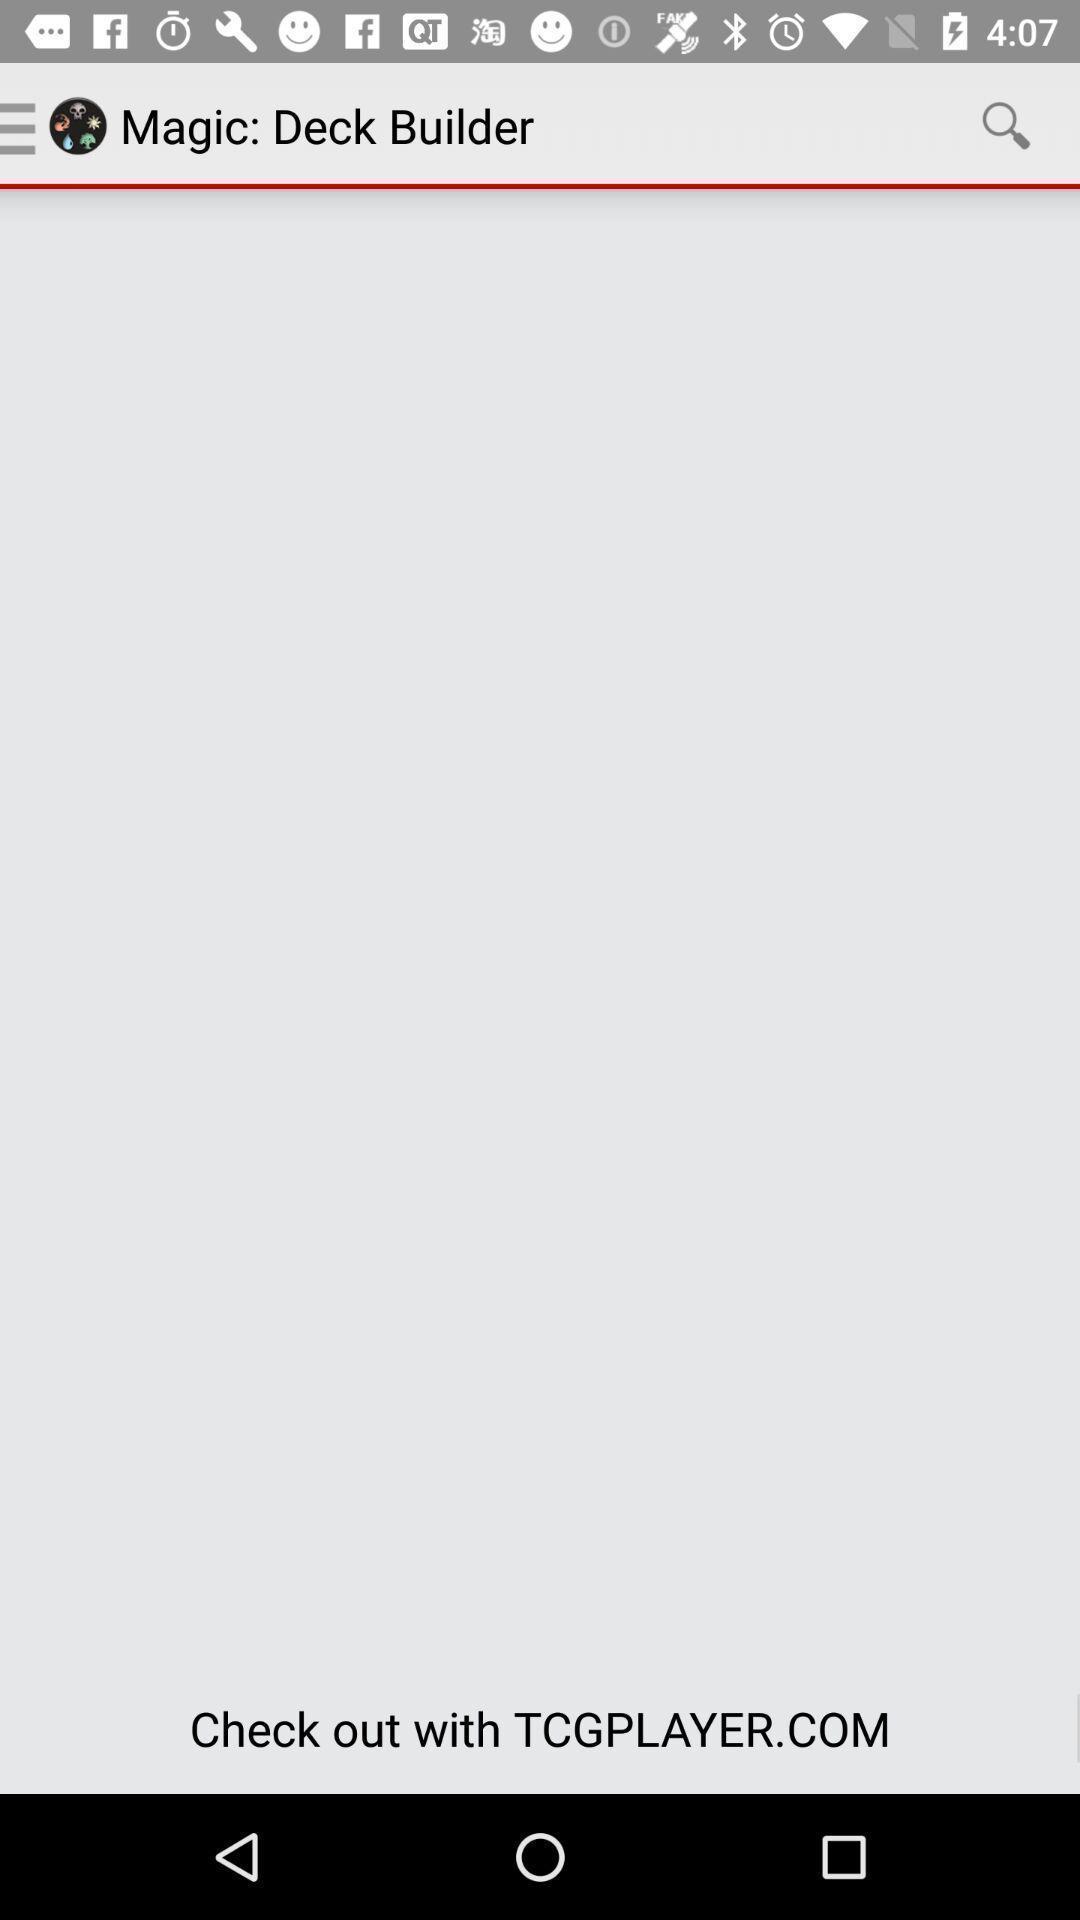Tell me about the visual elements in this screen capture. Search option to find magic. 